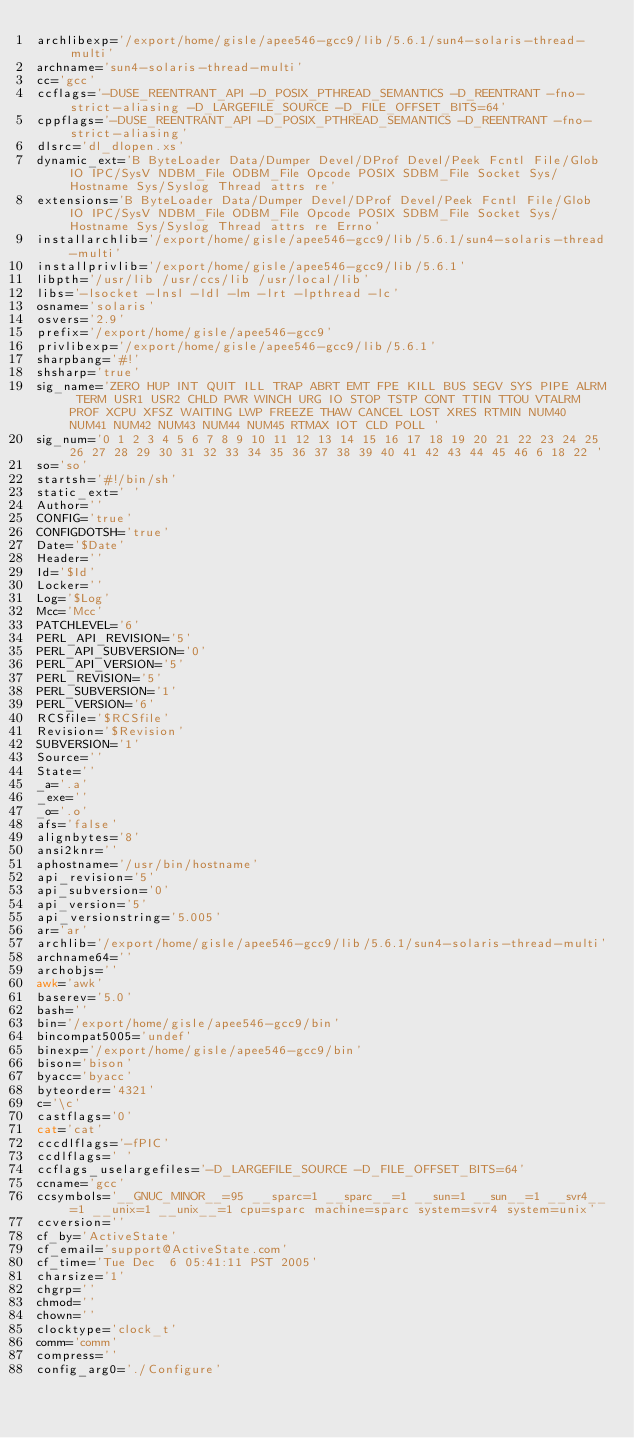<code> <loc_0><loc_0><loc_500><loc_500><_Bash_>archlibexp='/export/home/gisle/apee546-gcc9/lib/5.6.1/sun4-solaris-thread-multi'
archname='sun4-solaris-thread-multi'
cc='gcc'
ccflags='-DUSE_REENTRANT_API -D_POSIX_PTHREAD_SEMANTICS -D_REENTRANT -fno-strict-aliasing -D_LARGEFILE_SOURCE -D_FILE_OFFSET_BITS=64'
cppflags='-DUSE_REENTRANT_API -D_POSIX_PTHREAD_SEMANTICS -D_REENTRANT -fno-strict-aliasing'
dlsrc='dl_dlopen.xs'
dynamic_ext='B ByteLoader Data/Dumper Devel/DProf Devel/Peek Fcntl File/Glob IO IPC/SysV NDBM_File ODBM_File Opcode POSIX SDBM_File Socket Sys/Hostname Sys/Syslog Thread attrs re'
extensions='B ByteLoader Data/Dumper Devel/DProf Devel/Peek Fcntl File/Glob IO IPC/SysV NDBM_File ODBM_File Opcode POSIX SDBM_File Socket Sys/Hostname Sys/Syslog Thread attrs re Errno'
installarchlib='/export/home/gisle/apee546-gcc9/lib/5.6.1/sun4-solaris-thread-multi'
installprivlib='/export/home/gisle/apee546-gcc9/lib/5.6.1'
libpth='/usr/lib /usr/ccs/lib /usr/local/lib'
libs='-lsocket -lnsl -ldl -lm -lrt -lpthread -lc'
osname='solaris'
osvers='2.9'
prefix='/export/home/gisle/apee546-gcc9'
privlibexp='/export/home/gisle/apee546-gcc9/lib/5.6.1'
sharpbang='#!'
shsharp='true'
sig_name='ZERO HUP INT QUIT ILL TRAP ABRT EMT FPE KILL BUS SEGV SYS PIPE ALRM TERM USR1 USR2 CHLD PWR WINCH URG IO STOP TSTP CONT TTIN TTOU VTALRM PROF XCPU XFSZ WAITING LWP FREEZE THAW CANCEL LOST XRES RTMIN NUM40 NUM41 NUM42 NUM43 NUM44 NUM45 RTMAX IOT CLD POLL '
sig_num='0 1 2 3 4 5 6 7 8 9 10 11 12 13 14 15 16 17 18 19 20 21 22 23 24 25 26 27 28 29 30 31 32 33 34 35 36 37 38 39 40 41 42 43 44 45 46 6 18 22 '
so='so'
startsh='#!/bin/sh'
static_ext=' '
Author=''
CONFIG='true'
CONFIGDOTSH='true'
Date='$Date'
Header=''
Id='$Id'
Locker=''
Log='$Log'
Mcc='Mcc'
PATCHLEVEL='6'
PERL_API_REVISION='5'
PERL_API_SUBVERSION='0'
PERL_API_VERSION='5'
PERL_REVISION='5'
PERL_SUBVERSION='1'
PERL_VERSION='6'
RCSfile='$RCSfile'
Revision='$Revision'
SUBVERSION='1'
Source=''
State=''
_a='.a'
_exe=''
_o='.o'
afs='false'
alignbytes='8'
ansi2knr=''
aphostname='/usr/bin/hostname'
api_revision='5'
api_subversion='0'
api_version='5'
api_versionstring='5.005'
ar='ar'
archlib='/export/home/gisle/apee546-gcc9/lib/5.6.1/sun4-solaris-thread-multi'
archname64=''
archobjs=''
awk='awk'
baserev='5.0'
bash=''
bin='/export/home/gisle/apee546-gcc9/bin'
bincompat5005='undef'
binexp='/export/home/gisle/apee546-gcc9/bin'
bison='bison'
byacc='byacc'
byteorder='4321'
c='\c'
castflags='0'
cat='cat'
cccdlflags='-fPIC'
ccdlflags=' '
ccflags_uselargefiles='-D_LARGEFILE_SOURCE -D_FILE_OFFSET_BITS=64'
ccname='gcc'
ccsymbols='__GNUC_MINOR__=95 __sparc=1 __sparc__=1 __sun=1 __sun__=1 __svr4__=1 __unix=1 __unix__=1 cpu=sparc machine=sparc system=svr4 system=unix'
ccversion=''
cf_by='ActiveState'
cf_email='support@ActiveState.com'
cf_time='Tue Dec  6 05:41:11 PST 2005'
charsize='1'
chgrp=''
chmod=''
chown=''
clocktype='clock_t'
comm='comm'
compress=''
config_arg0='./Configure'</code> 